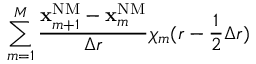<formula> <loc_0><loc_0><loc_500><loc_500>\sum _ { m = 1 } ^ { M } \frac { x _ { m + 1 } ^ { N M } - x _ { m } ^ { N M } } { \Delta r } \chi _ { m } ( r - \frac { 1 } { 2 } \Delta r )</formula> 